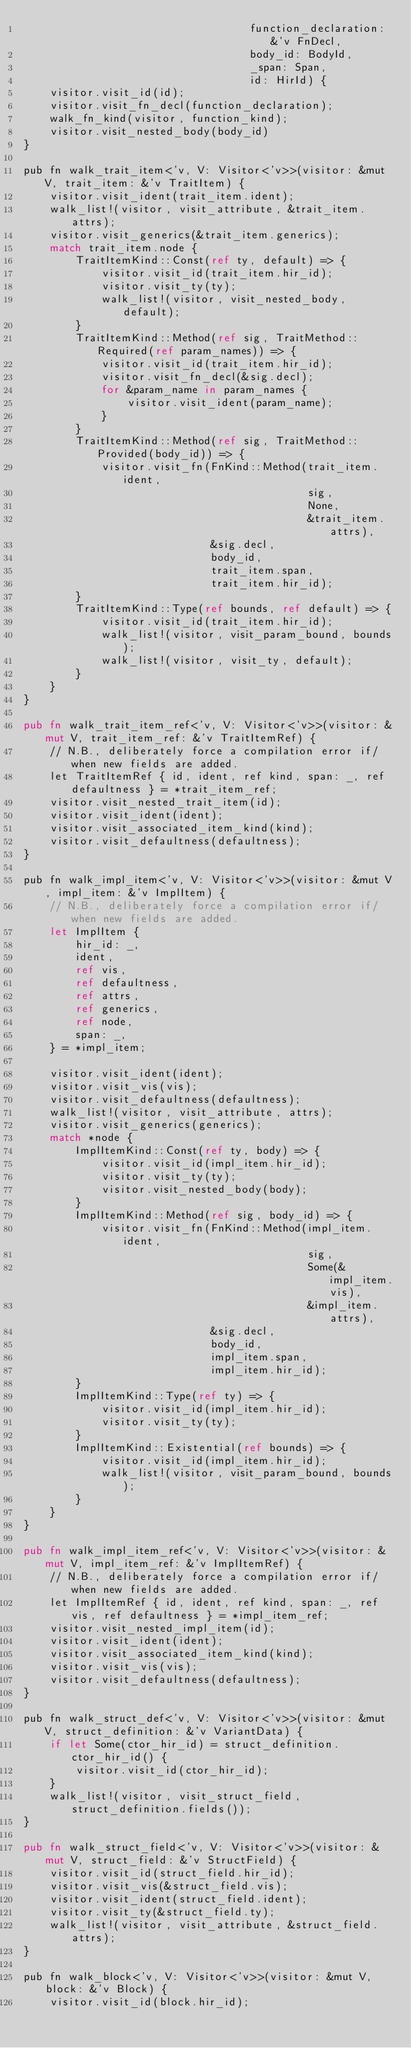Convert code to text. <code><loc_0><loc_0><loc_500><loc_500><_Rust_>                                   function_declaration: &'v FnDecl,
                                   body_id: BodyId,
                                   _span: Span,
                                   id: HirId) {
    visitor.visit_id(id);
    visitor.visit_fn_decl(function_declaration);
    walk_fn_kind(visitor, function_kind);
    visitor.visit_nested_body(body_id)
}

pub fn walk_trait_item<'v, V: Visitor<'v>>(visitor: &mut V, trait_item: &'v TraitItem) {
    visitor.visit_ident(trait_item.ident);
    walk_list!(visitor, visit_attribute, &trait_item.attrs);
    visitor.visit_generics(&trait_item.generics);
    match trait_item.node {
        TraitItemKind::Const(ref ty, default) => {
            visitor.visit_id(trait_item.hir_id);
            visitor.visit_ty(ty);
            walk_list!(visitor, visit_nested_body, default);
        }
        TraitItemKind::Method(ref sig, TraitMethod::Required(ref param_names)) => {
            visitor.visit_id(trait_item.hir_id);
            visitor.visit_fn_decl(&sig.decl);
            for &param_name in param_names {
                visitor.visit_ident(param_name);
            }
        }
        TraitItemKind::Method(ref sig, TraitMethod::Provided(body_id)) => {
            visitor.visit_fn(FnKind::Method(trait_item.ident,
                                            sig,
                                            None,
                                            &trait_item.attrs),
                             &sig.decl,
                             body_id,
                             trait_item.span,
                             trait_item.hir_id);
        }
        TraitItemKind::Type(ref bounds, ref default) => {
            visitor.visit_id(trait_item.hir_id);
            walk_list!(visitor, visit_param_bound, bounds);
            walk_list!(visitor, visit_ty, default);
        }
    }
}

pub fn walk_trait_item_ref<'v, V: Visitor<'v>>(visitor: &mut V, trait_item_ref: &'v TraitItemRef) {
    // N.B., deliberately force a compilation error if/when new fields are added.
    let TraitItemRef { id, ident, ref kind, span: _, ref defaultness } = *trait_item_ref;
    visitor.visit_nested_trait_item(id);
    visitor.visit_ident(ident);
    visitor.visit_associated_item_kind(kind);
    visitor.visit_defaultness(defaultness);
}

pub fn walk_impl_item<'v, V: Visitor<'v>>(visitor: &mut V, impl_item: &'v ImplItem) {
    // N.B., deliberately force a compilation error if/when new fields are added.
    let ImplItem {
        hir_id: _,
        ident,
        ref vis,
        ref defaultness,
        ref attrs,
        ref generics,
        ref node,
        span: _,
    } = *impl_item;

    visitor.visit_ident(ident);
    visitor.visit_vis(vis);
    visitor.visit_defaultness(defaultness);
    walk_list!(visitor, visit_attribute, attrs);
    visitor.visit_generics(generics);
    match *node {
        ImplItemKind::Const(ref ty, body) => {
            visitor.visit_id(impl_item.hir_id);
            visitor.visit_ty(ty);
            visitor.visit_nested_body(body);
        }
        ImplItemKind::Method(ref sig, body_id) => {
            visitor.visit_fn(FnKind::Method(impl_item.ident,
                                            sig,
                                            Some(&impl_item.vis),
                                            &impl_item.attrs),
                             &sig.decl,
                             body_id,
                             impl_item.span,
                             impl_item.hir_id);
        }
        ImplItemKind::Type(ref ty) => {
            visitor.visit_id(impl_item.hir_id);
            visitor.visit_ty(ty);
        }
        ImplItemKind::Existential(ref bounds) => {
            visitor.visit_id(impl_item.hir_id);
            walk_list!(visitor, visit_param_bound, bounds);
        }
    }
}

pub fn walk_impl_item_ref<'v, V: Visitor<'v>>(visitor: &mut V, impl_item_ref: &'v ImplItemRef) {
    // N.B., deliberately force a compilation error if/when new fields are added.
    let ImplItemRef { id, ident, ref kind, span: _, ref vis, ref defaultness } = *impl_item_ref;
    visitor.visit_nested_impl_item(id);
    visitor.visit_ident(ident);
    visitor.visit_associated_item_kind(kind);
    visitor.visit_vis(vis);
    visitor.visit_defaultness(defaultness);
}

pub fn walk_struct_def<'v, V: Visitor<'v>>(visitor: &mut V, struct_definition: &'v VariantData) {
    if let Some(ctor_hir_id) = struct_definition.ctor_hir_id() {
        visitor.visit_id(ctor_hir_id);
    }
    walk_list!(visitor, visit_struct_field, struct_definition.fields());
}

pub fn walk_struct_field<'v, V: Visitor<'v>>(visitor: &mut V, struct_field: &'v StructField) {
    visitor.visit_id(struct_field.hir_id);
    visitor.visit_vis(&struct_field.vis);
    visitor.visit_ident(struct_field.ident);
    visitor.visit_ty(&struct_field.ty);
    walk_list!(visitor, visit_attribute, &struct_field.attrs);
}

pub fn walk_block<'v, V: Visitor<'v>>(visitor: &mut V, block: &'v Block) {
    visitor.visit_id(block.hir_id);</code> 